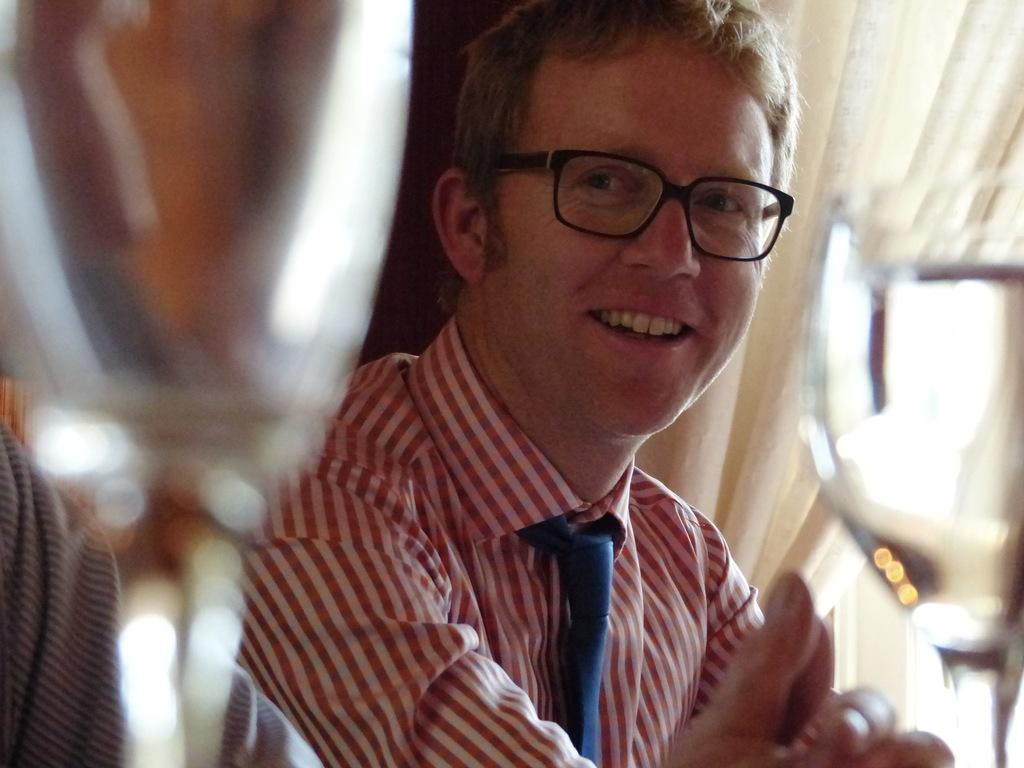Who or what is present in the image? There is a person in the image. What is the person wearing around their neck? The person is wearing a tie. What type of eyewear is the person wearing? The person is wearing spectacles. What can be seen in the background of the image? There is a curtain in the background of the image. What type of wine is being served on the sand in the image? There is no wine or sand present in the image; it features a person wearing a tie and spectacles with a curtain in the background. 